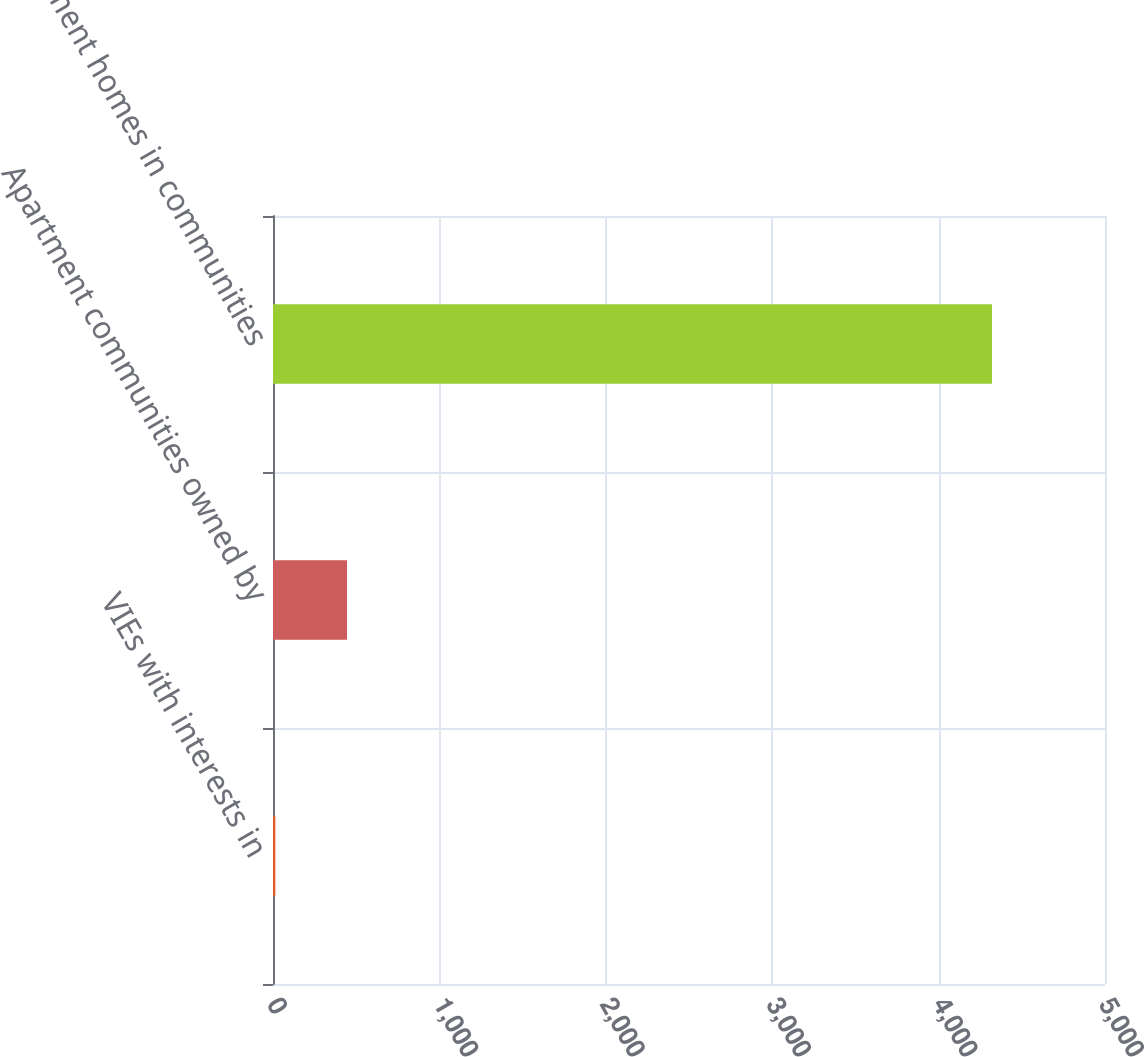Convert chart. <chart><loc_0><loc_0><loc_500><loc_500><bar_chart><fcel>VIEs with interests in<fcel>Apartment communities owned by<fcel>Apartment homes in communities<nl><fcel>14<fcel>444.7<fcel>4321<nl></chart> 